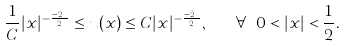<formula> <loc_0><loc_0><loc_500><loc_500>\frac { 1 } { C } | x | ^ { - \frac { n - 2 } 2 } \leq u ( x ) \leq C | x | ^ { - \frac { n - 2 } 2 } , \quad \forall \ 0 < | x | < \frac { 1 } { 2 } .</formula> 